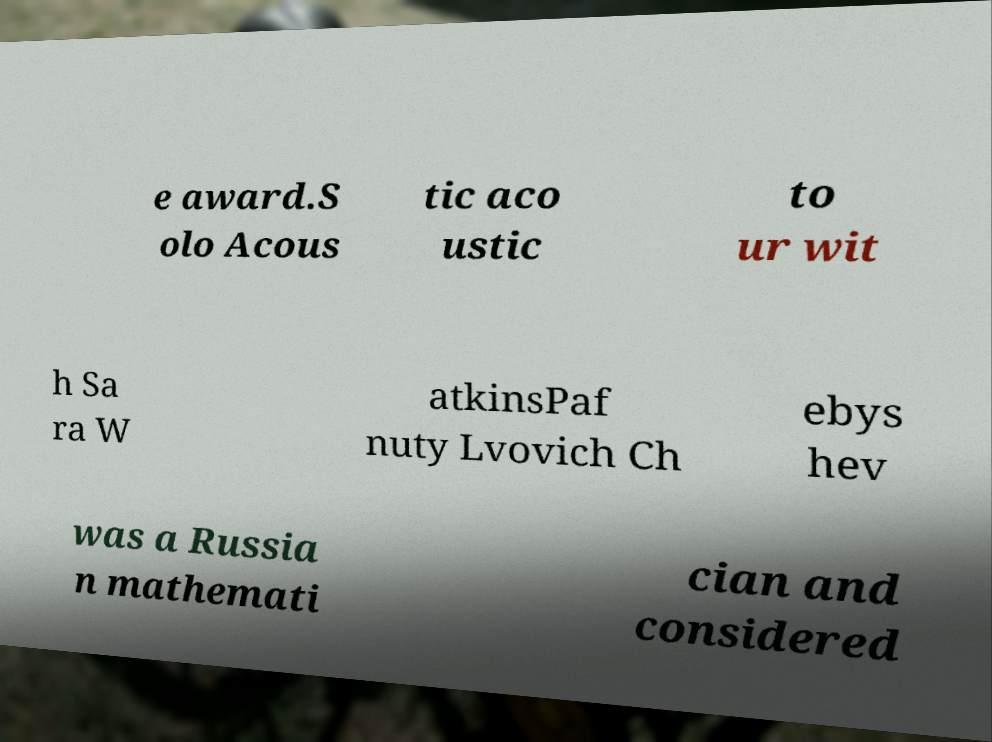For documentation purposes, I need the text within this image transcribed. Could you provide that? e award.S olo Acous tic aco ustic to ur wit h Sa ra W atkinsPaf nuty Lvovich Ch ebys hev was a Russia n mathemati cian and considered 